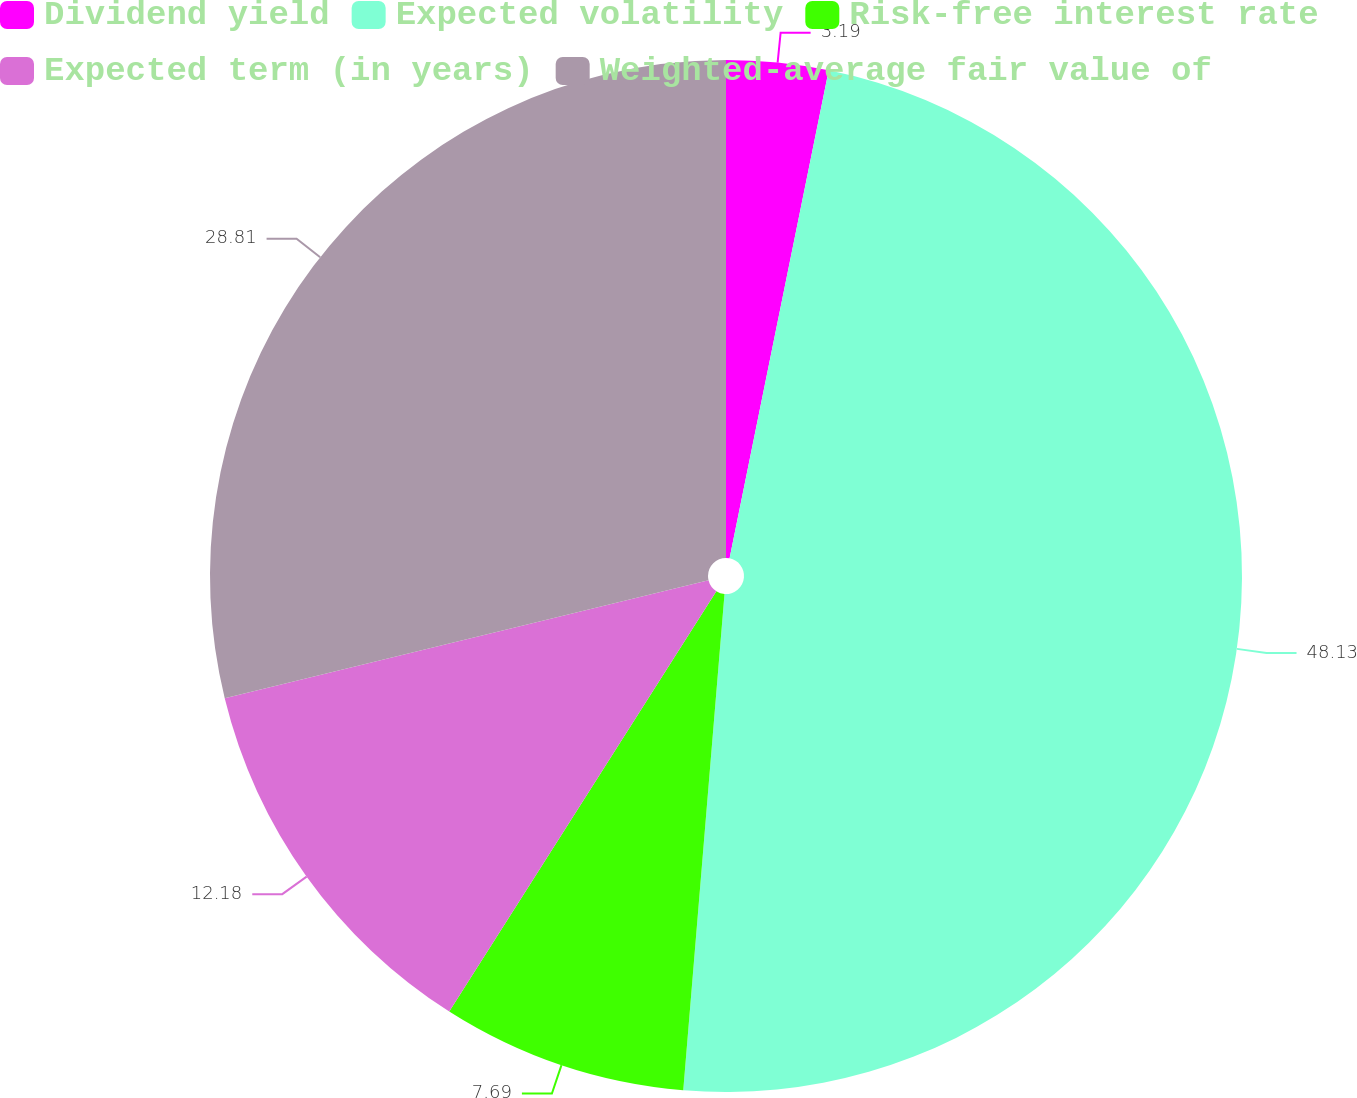<chart> <loc_0><loc_0><loc_500><loc_500><pie_chart><fcel>Dividend yield<fcel>Expected volatility<fcel>Risk-free interest rate<fcel>Expected term (in years)<fcel>Weighted-average fair value of<nl><fcel>3.19%<fcel>48.13%<fcel>7.69%<fcel>12.18%<fcel>28.81%<nl></chart> 